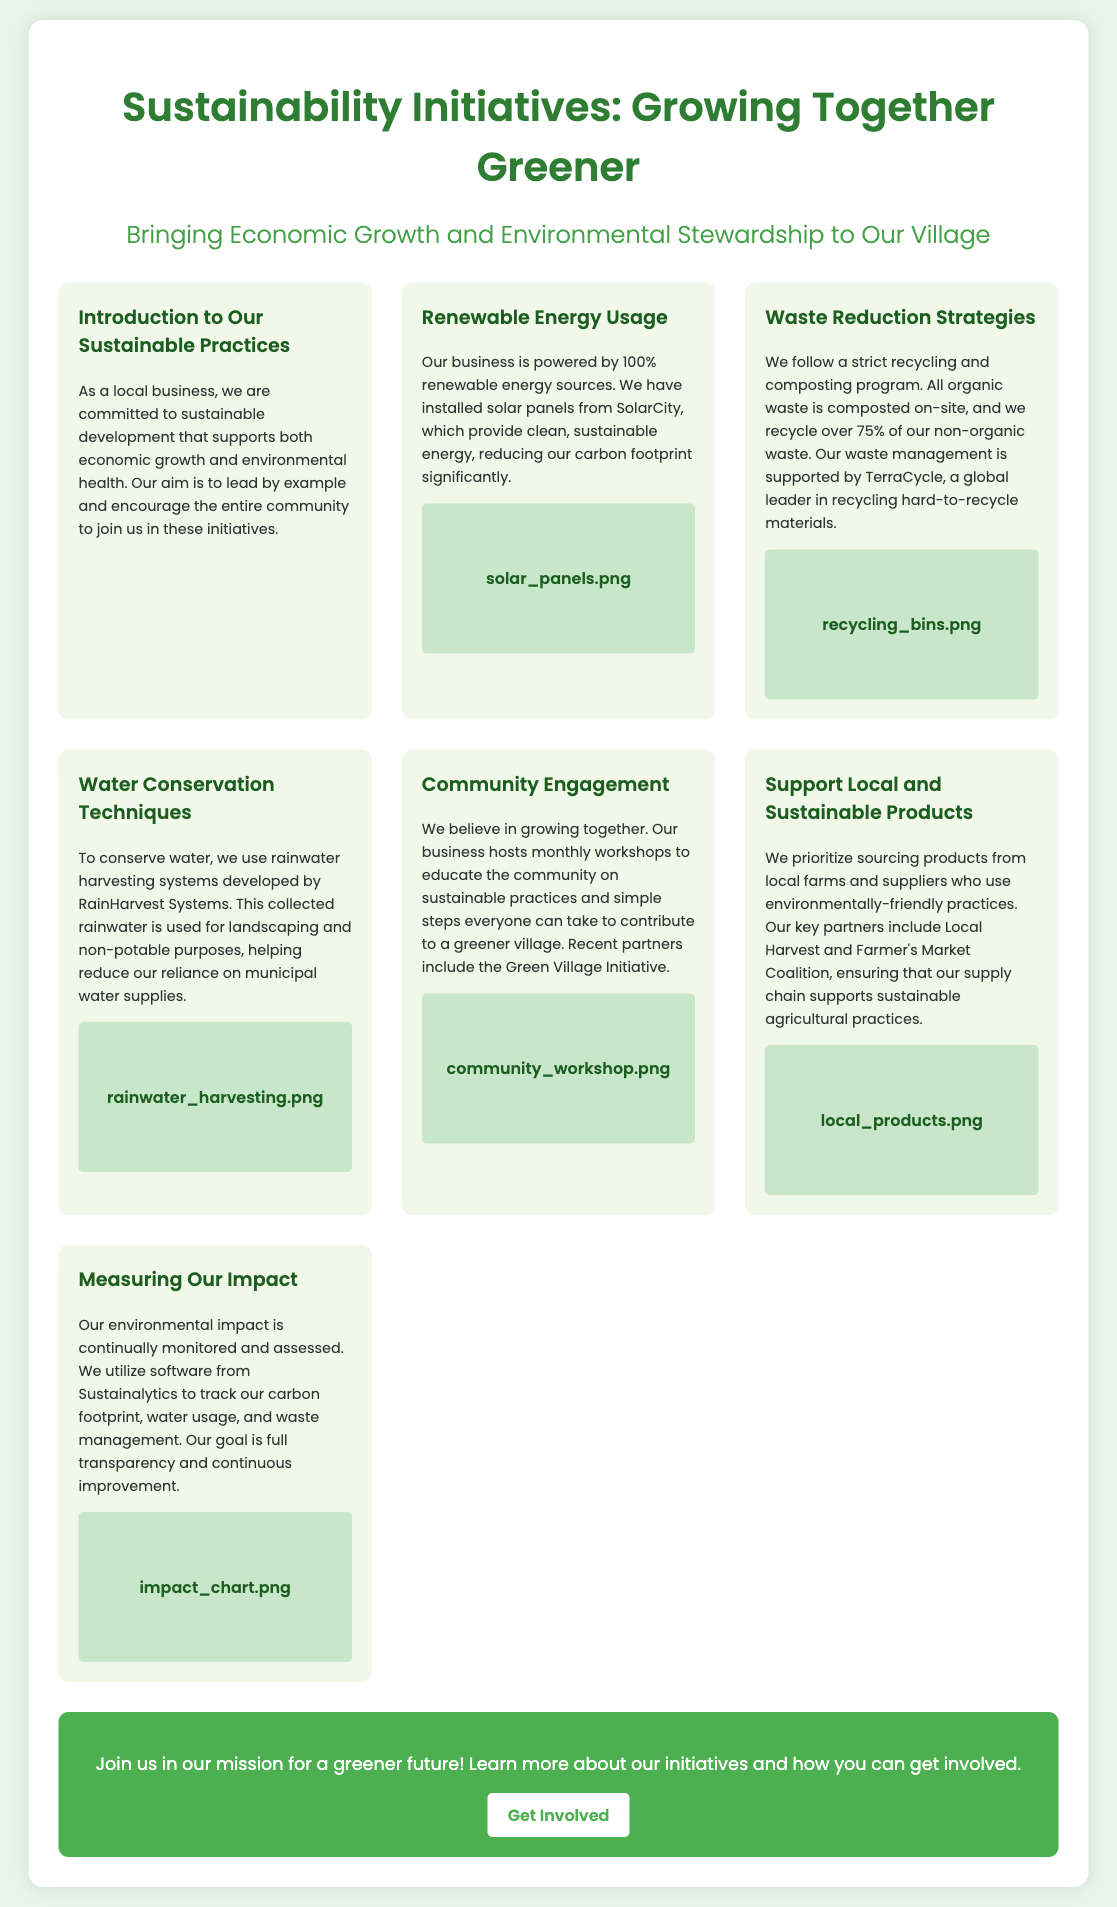What is the title of the initiative? The title is mentioned prominently at the top of the poster.
Answer: Sustainability Initiatives: Growing Together Greener What is the main energy source used by the business? The document states the business uses renewable energy sources.
Answer: Renewable energy What percentage of non-organic waste is recycled? The document provides a specific percentage for non-organic waste recycling.
Answer: 75% What system is used for water conservation? The document describes a specific system developed by a named company.
Answer: Rainwater harvesting What does the business offer to engage the community? The document highlights activities the business provides to involve the community.
Answer: Monthly workshops Who supports the waste management program? The document refers to a specific organization that aids in their waste management efforts.
Answer: TerraCycle How does the business track its environmental impact? The document mentions a tool used to monitor various environmental metrics.
Answer: Sustainalytics What do the workshops aim to educate on? The document outlines the general topic covered in the workshops.
Answer: Sustainable practices What is the primary goal of the poster? The purpose of the poster is explained in the call to action section.
Answer: Encourage community involvement 